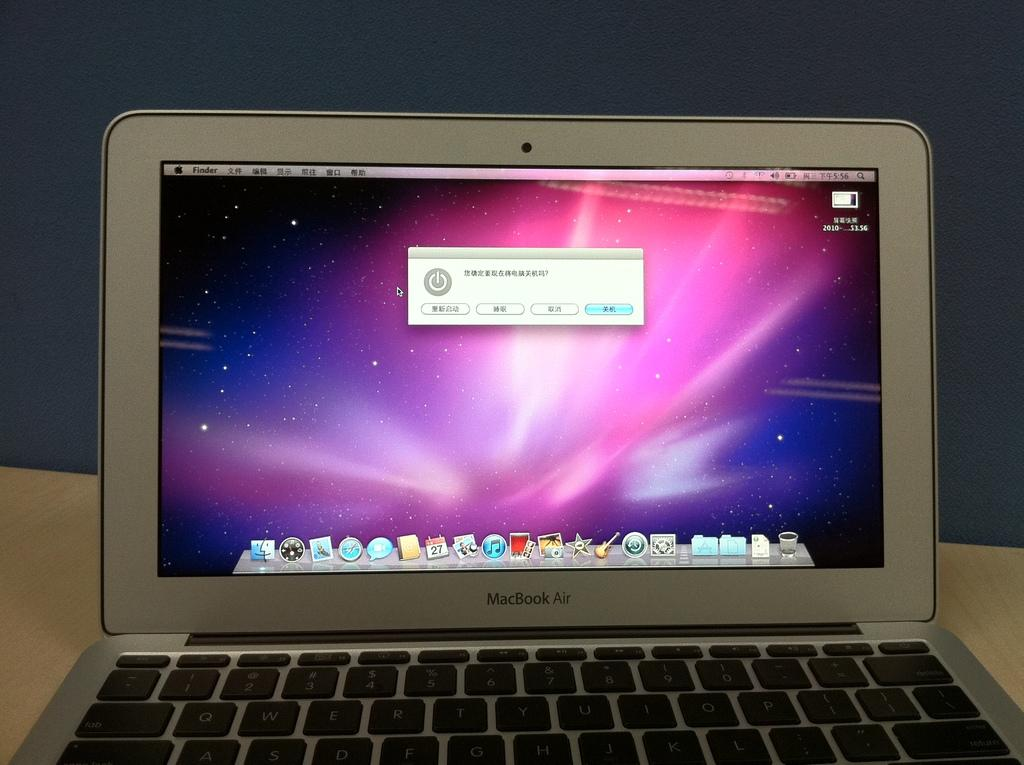<image>
Provide a brief description of the given image. A MacBook Air is open and powered on. 